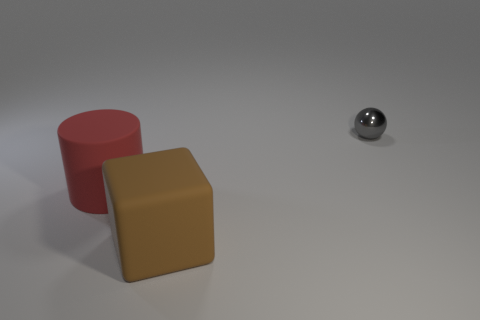Is the size of the object that is left of the large brown matte block the same as the object behind the red rubber object?
Provide a succinct answer. No. How many other objects are there of the same size as the red rubber cylinder?
Offer a terse response. 1. How many things are things behind the big brown cube or things that are to the right of the large matte cylinder?
Give a very brief answer. 3. Is the material of the red cylinder the same as the thing right of the large matte cube?
Give a very brief answer. No. How many other things are there of the same shape as the big red rubber thing?
Your answer should be compact. 0. What material is the large thing in front of the big rubber object that is to the left of the large matte object right of the red rubber object?
Provide a succinct answer. Rubber. Are there the same number of brown blocks on the left side of the large rubber block and big cyan balls?
Your answer should be compact. Yes. Are the thing behind the large cylinder and the big object behind the brown matte block made of the same material?
Your answer should be compact. No. Is there anything else that is the same material as the sphere?
Your answer should be compact. No. There is a object on the right side of the large brown object; is its shape the same as the rubber thing on the left side of the large brown block?
Your response must be concise. No. 